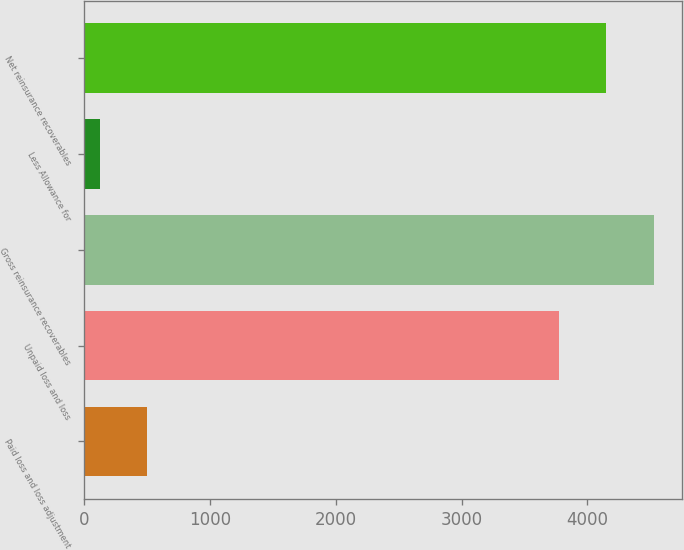Convert chart. <chart><loc_0><loc_0><loc_500><loc_500><bar_chart><fcel>Paid loss and loss adjustment<fcel>Unpaid loss and loss<fcel>Gross reinsurance recoverables<fcel>Less Allowance for<fcel>Net reinsurance recoverables<nl><fcel>503.4<fcel>3773<fcel>4527.8<fcel>126<fcel>4150.4<nl></chart> 